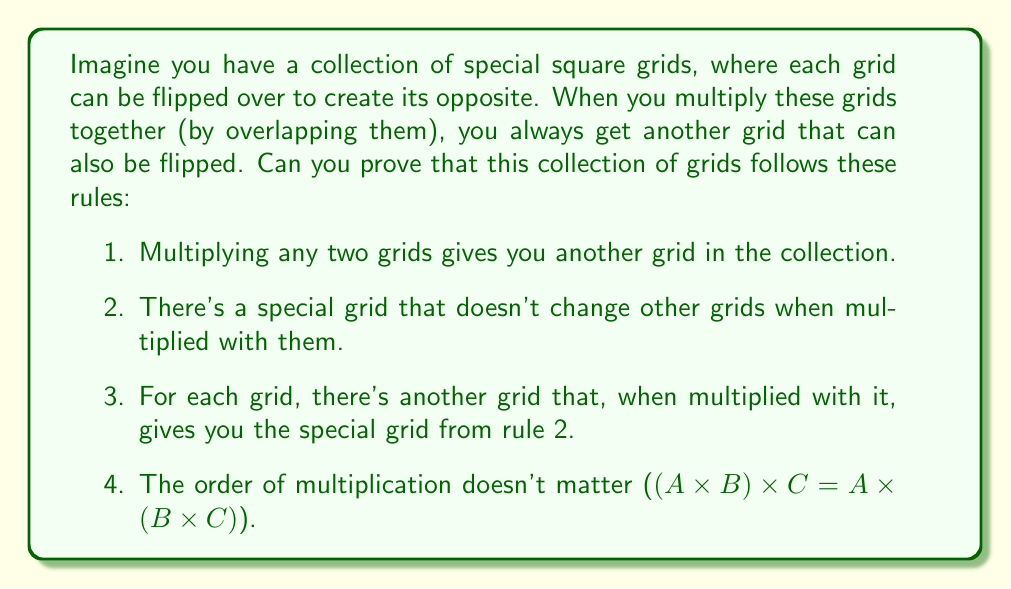Give your solution to this math problem. Let's break this down step-by-step:

1. Closure:
   We need to show that multiplying any two invertible matrices results in another invertible matrix.
   Let $A$ and $B$ be invertible matrices. Their product $AB$ is invertible because:
   $$(AB)(B^{-1}A^{-1}) = A(BB^{-1})A^{-1} = AIA^{-1} = AA^{-1} = I$$
   So, $(AB)^{-1} = B^{-1}A^{-1}$ exists, proving $AB$ is invertible.

2. Identity element:
   The identity matrix $I$ serves as the identity element because for any invertible matrix $A$:
   $$AI = IA = A$$

3. Inverse element:
   For any invertible matrix $A$, its inverse $A^{-1}$ exists by definition, and:
   $$AA^{-1} = A^{-1}A = I$$

4. Associativity:
   Matrix multiplication is always associative, so for any invertible matrices $A$, $B$, and $C$:
   $$(AB)C = A(BC)$$

These four properties (closure, identity element, inverse element, and associativity) are the defining characteristics of a group. Since the set of invertible matrices satisfies all four, it forms a group under matrix multiplication.
Answer: The set of invertible matrices forms a group under matrix multiplication because it satisfies the four group axioms: closure, identity element, inverse element, and associativity. 